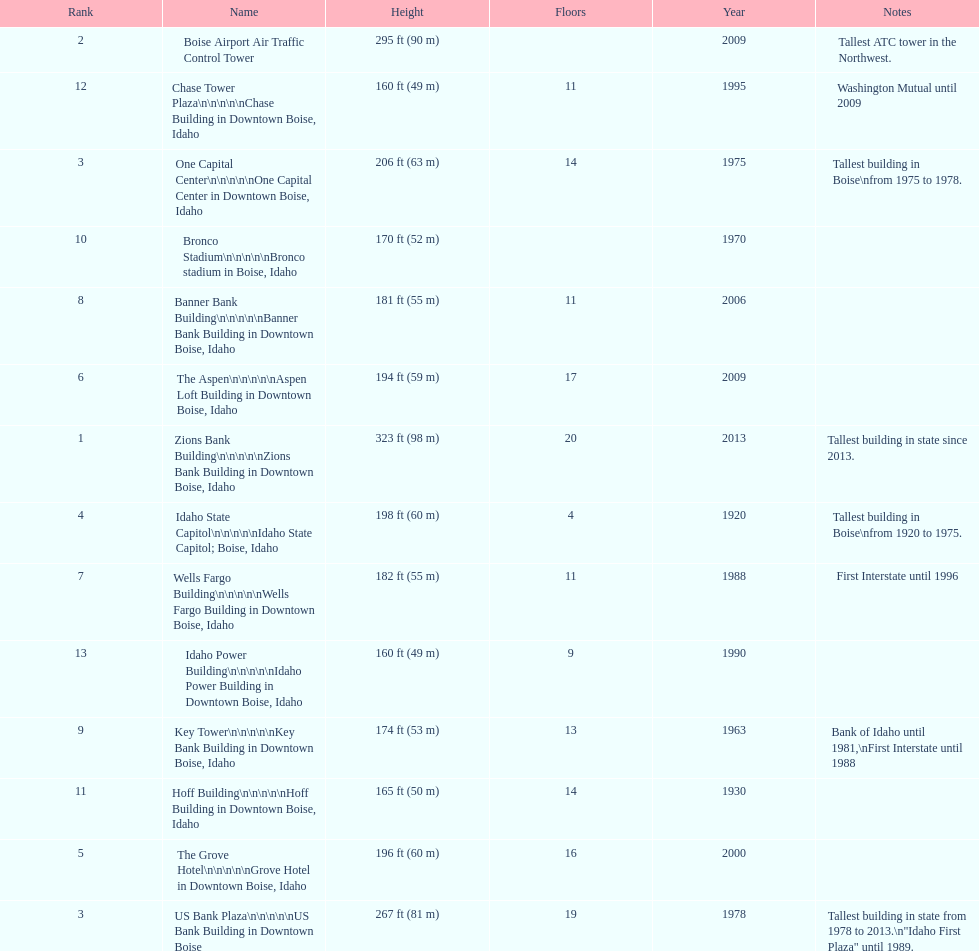In boise, idaho, which structure has the greatest height? Zions Bank Building Zions Bank Building in Downtown Boise, Idaho. 